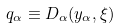Convert formula to latex. <formula><loc_0><loc_0><loc_500><loc_500>q _ { \alpha } \equiv D _ { \alpha } ( y _ { \alpha } , \xi )</formula> 